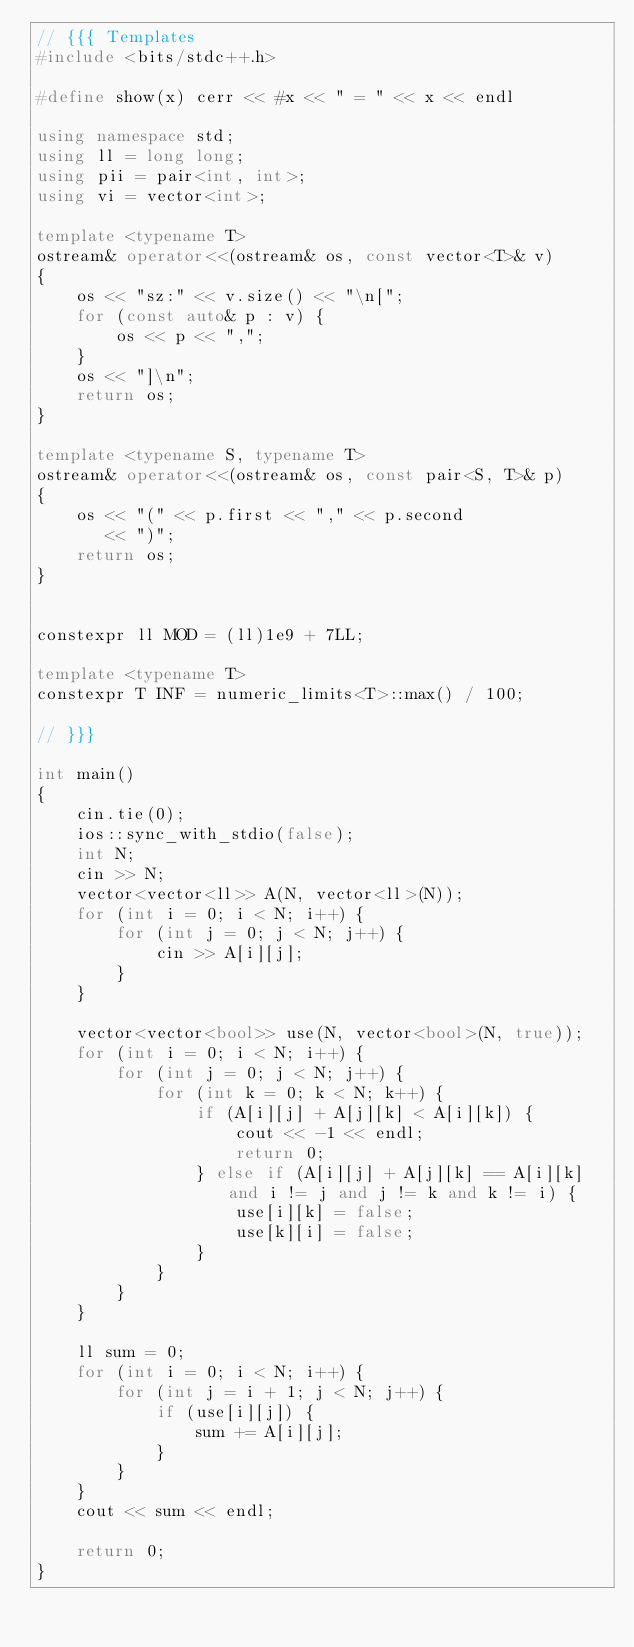<code> <loc_0><loc_0><loc_500><loc_500><_C++_>// {{{ Templates
#include <bits/stdc++.h>

#define show(x) cerr << #x << " = " << x << endl

using namespace std;
using ll = long long;
using pii = pair<int, int>;
using vi = vector<int>;

template <typename T>
ostream& operator<<(ostream& os, const vector<T>& v)
{
    os << "sz:" << v.size() << "\n[";
    for (const auto& p : v) {
        os << p << ",";
    }
    os << "]\n";
    return os;
}

template <typename S, typename T>
ostream& operator<<(ostream& os, const pair<S, T>& p)
{
    os << "(" << p.first << "," << p.second
       << ")";
    return os;
}


constexpr ll MOD = (ll)1e9 + 7LL;

template <typename T>
constexpr T INF = numeric_limits<T>::max() / 100;

// }}}

int main()
{
    cin.tie(0);
    ios::sync_with_stdio(false);
    int N;
    cin >> N;
    vector<vector<ll>> A(N, vector<ll>(N));
    for (int i = 0; i < N; i++) {
        for (int j = 0; j < N; j++) {
            cin >> A[i][j];
        }
    }

    vector<vector<bool>> use(N, vector<bool>(N, true));
    for (int i = 0; i < N; i++) {
        for (int j = 0; j < N; j++) {
            for (int k = 0; k < N; k++) {
                if (A[i][j] + A[j][k] < A[i][k]) {
                    cout << -1 << endl;
                    return 0;
                } else if (A[i][j] + A[j][k] == A[i][k] and i != j and j != k and k != i) {
                    use[i][k] = false;
                    use[k][i] = false;
                }
            }
        }
    }

    ll sum = 0;
    for (int i = 0; i < N; i++) {
        for (int j = i + 1; j < N; j++) {
            if (use[i][j]) {
                sum += A[i][j];
            }
        }
    }
    cout << sum << endl;

    return 0;
}
</code> 